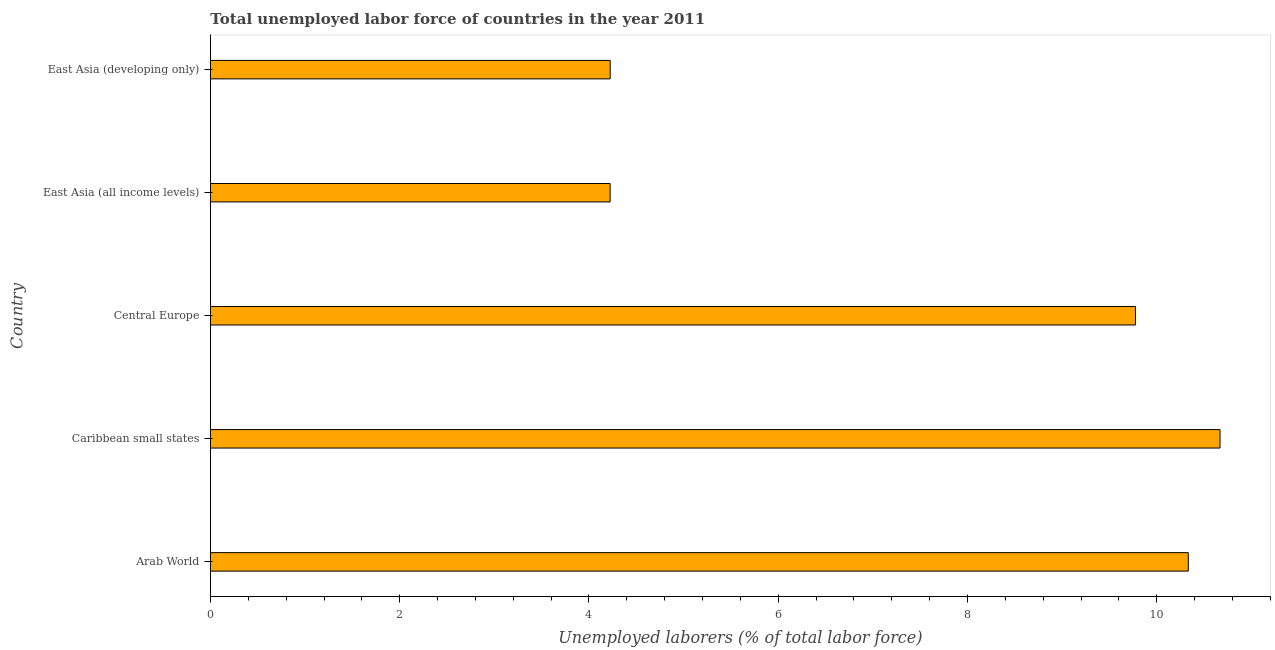Does the graph contain any zero values?
Your response must be concise. No. Does the graph contain grids?
Provide a short and direct response. No. What is the title of the graph?
Offer a terse response. Total unemployed labor force of countries in the year 2011. What is the label or title of the X-axis?
Keep it short and to the point. Unemployed laborers (% of total labor force). What is the total unemployed labour force in Central Europe?
Make the answer very short. 9.78. Across all countries, what is the maximum total unemployed labour force?
Make the answer very short. 10.67. Across all countries, what is the minimum total unemployed labour force?
Keep it short and to the point. 4.22. In which country was the total unemployed labour force maximum?
Offer a terse response. Caribbean small states. In which country was the total unemployed labour force minimum?
Your answer should be very brief. East Asia (all income levels). What is the sum of the total unemployed labour force?
Give a very brief answer. 39.22. What is the difference between the total unemployed labour force in East Asia (all income levels) and East Asia (developing only)?
Provide a succinct answer. -0. What is the average total unemployed labour force per country?
Provide a short and direct response. 7.84. What is the median total unemployed labour force?
Offer a terse response. 9.78. In how many countries, is the total unemployed labour force greater than 3.6 %?
Offer a terse response. 5. What is the ratio of the total unemployed labour force in Arab World to that in East Asia (developing only)?
Provide a succinct answer. 2.45. What is the difference between the highest and the second highest total unemployed labour force?
Provide a succinct answer. 0.34. Is the sum of the total unemployed labour force in Caribbean small states and East Asia (developing only) greater than the maximum total unemployed labour force across all countries?
Make the answer very short. Yes. What is the difference between the highest and the lowest total unemployed labour force?
Make the answer very short. 6.45. How many bars are there?
Give a very brief answer. 5. How many countries are there in the graph?
Offer a terse response. 5. What is the difference between two consecutive major ticks on the X-axis?
Give a very brief answer. 2. What is the Unemployed laborers (% of total labor force) in Arab World?
Make the answer very short. 10.33. What is the Unemployed laborers (% of total labor force) of Caribbean small states?
Provide a succinct answer. 10.67. What is the Unemployed laborers (% of total labor force) in Central Europe?
Give a very brief answer. 9.78. What is the Unemployed laborers (% of total labor force) of East Asia (all income levels)?
Your response must be concise. 4.22. What is the Unemployed laborers (% of total labor force) of East Asia (developing only)?
Your response must be concise. 4.22. What is the difference between the Unemployed laborers (% of total labor force) in Arab World and Caribbean small states?
Ensure brevity in your answer.  -0.34. What is the difference between the Unemployed laborers (% of total labor force) in Arab World and Central Europe?
Offer a very short reply. 0.56. What is the difference between the Unemployed laborers (% of total labor force) in Arab World and East Asia (all income levels)?
Your answer should be very brief. 6.11. What is the difference between the Unemployed laborers (% of total labor force) in Arab World and East Asia (developing only)?
Provide a succinct answer. 6.11. What is the difference between the Unemployed laborers (% of total labor force) in Caribbean small states and Central Europe?
Keep it short and to the point. 0.89. What is the difference between the Unemployed laborers (% of total labor force) in Caribbean small states and East Asia (all income levels)?
Offer a very short reply. 6.45. What is the difference between the Unemployed laborers (% of total labor force) in Caribbean small states and East Asia (developing only)?
Your answer should be very brief. 6.44. What is the difference between the Unemployed laborers (% of total labor force) in Central Europe and East Asia (all income levels)?
Keep it short and to the point. 5.55. What is the difference between the Unemployed laborers (% of total labor force) in Central Europe and East Asia (developing only)?
Offer a very short reply. 5.55. What is the difference between the Unemployed laborers (% of total labor force) in East Asia (all income levels) and East Asia (developing only)?
Offer a terse response. -0. What is the ratio of the Unemployed laborers (% of total labor force) in Arab World to that in Caribbean small states?
Offer a terse response. 0.97. What is the ratio of the Unemployed laborers (% of total labor force) in Arab World to that in Central Europe?
Give a very brief answer. 1.06. What is the ratio of the Unemployed laborers (% of total labor force) in Arab World to that in East Asia (all income levels)?
Make the answer very short. 2.45. What is the ratio of the Unemployed laborers (% of total labor force) in Arab World to that in East Asia (developing only)?
Keep it short and to the point. 2.45. What is the ratio of the Unemployed laborers (% of total labor force) in Caribbean small states to that in Central Europe?
Make the answer very short. 1.09. What is the ratio of the Unemployed laborers (% of total labor force) in Caribbean small states to that in East Asia (all income levels)?
Ensure brevity in your answer.  2.53. What is the ratio of the Unemployed laborers (% of total labor force) in Caribbean small states to that in East Asia (developing only)?
Provide a succinct answer. 2.53. What is the ratio of the Unemployed laborers (% of total labor force) in Central Europe to that in East Asia (all income levels)?
Ensure brevity in your answer.  2.31. What is the ratio of the Unemployed laborers (% of total labor force) in Central Europe to that in East Asia (developing only)?
Your answer should be compact. 2.31. 